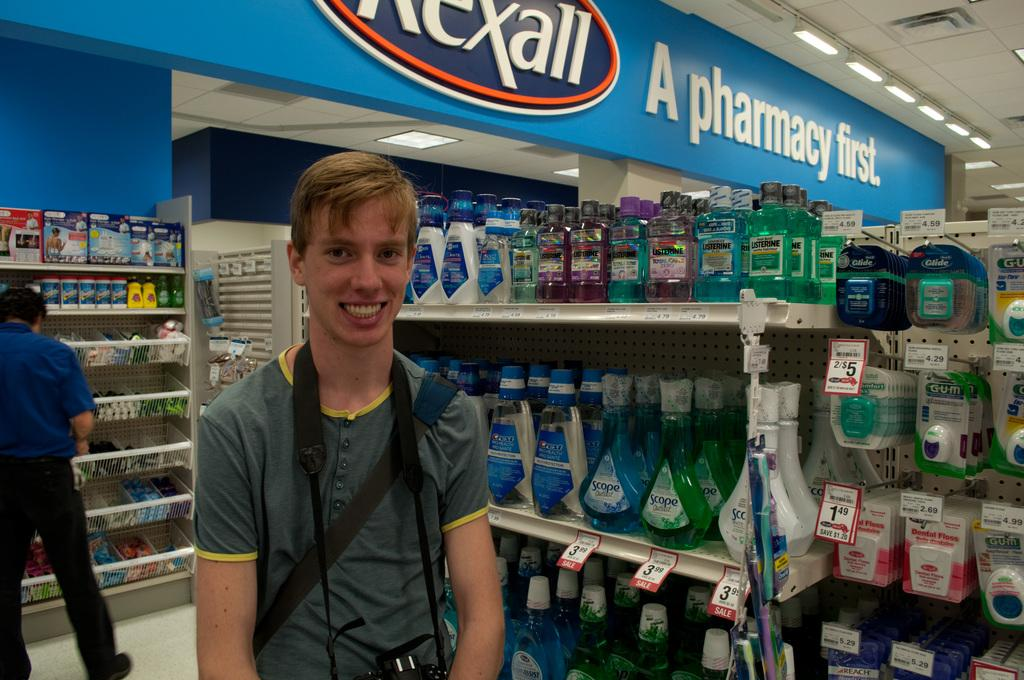<image>
Present a compact description of the photo's key features. A blonde man is smiling in front of a blue pharmacy. 